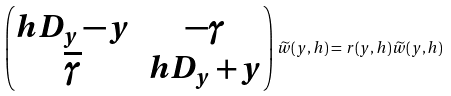Convert formula to latex. <formula><loc_0><loc_0><loc_500><loc_500>\begin{pmatrix} h D _ { y } - y & - \gamma \\ \overline { \gamma } & h D _ { y } + y \end{pmatrix} \widetilde { w } ( y , h ) = r ( y , h ) \widetilde { w } ( y , h )</formula> 